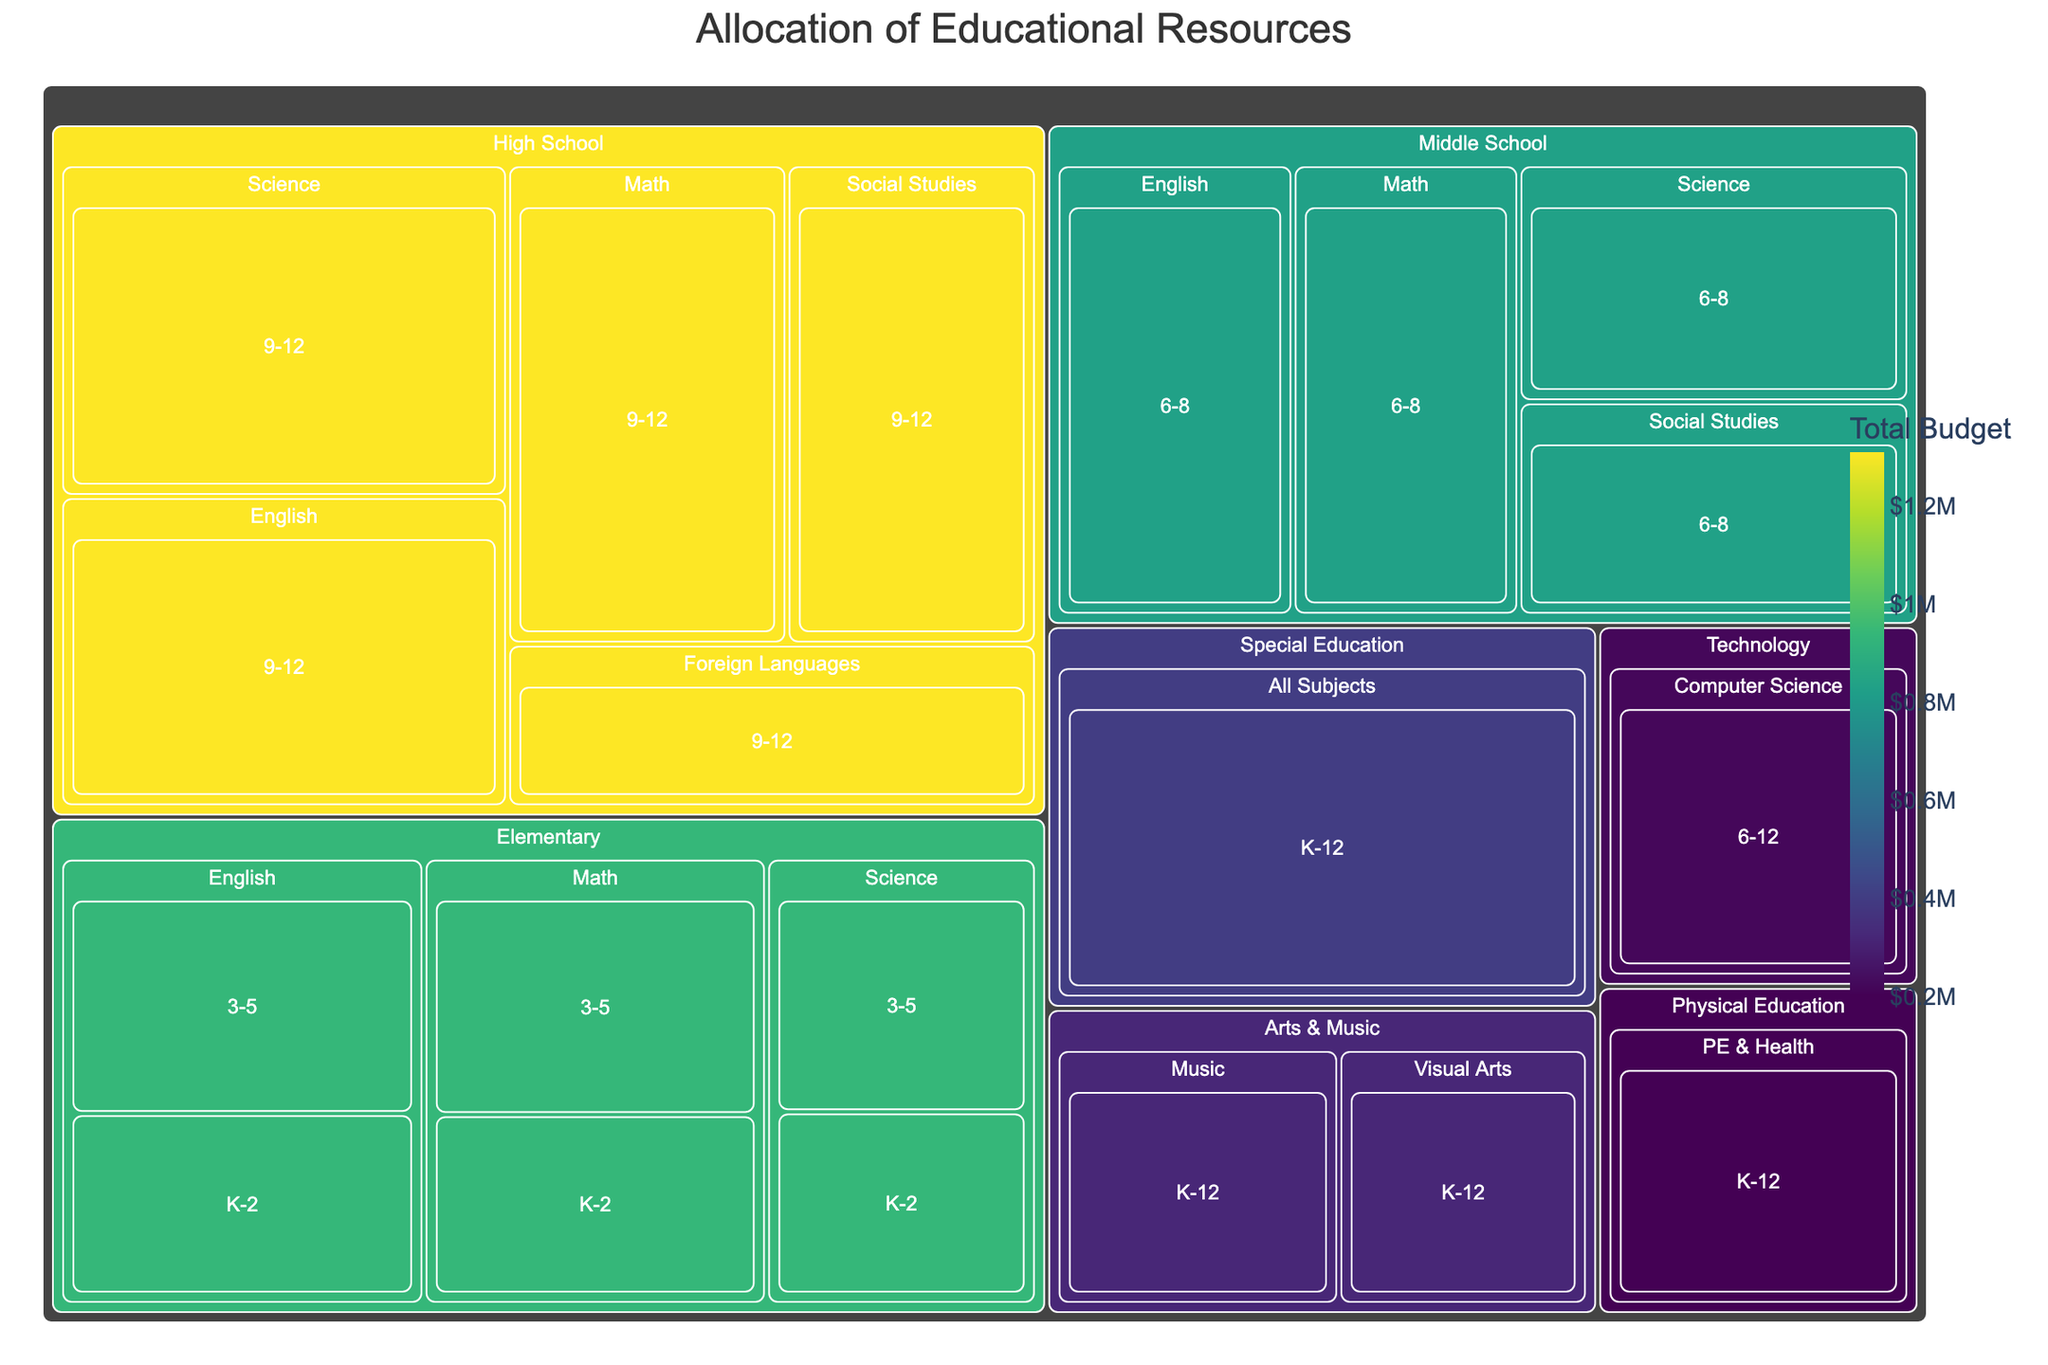Which department received the highest total budget? By examining the treemap, locate the department with the largest area, which indicates the highest total budget allocated. The color intensity can also guide you as it corresponds to the total budget.
Answer: Special Education What is the budget allocated to High School Science for grades 9-12? Navigate to the High School section in the treemap and find the Science subject for grades 9-12. The value displayed represents the budget.
Answer: $310,000 How does the budget for Computer Science in Middle and High School compare to the budget for Physical Education? Locate the Computer Science section under the Technology department and compare its budget to the Physical Education (PE & Health) section under Physical Education. Check the budget values to see which is higher.
Answer: Computer Science: $220,000, Physical Education: $200,000 Which subject in Elementary school for grades 3-5 has the highest budget? Within the Elementary school section, look at the subjects for grades 3-5 and compare their budgets. Identify the subject with the highest value.
Answer: English What is the total budget allocated to Middle School subjects? Sum the individual budgets for all Middle School subjects (Math, English, Science, Social Studies) by identifying their respective areas in the treemap and adding their values.
Answer: $830,000 Compare the budget for Math in Elementary school for grades K-2 with the budget for Elementary Science for grades 3-5. Which is higher and by how much? Locate the respective budgets for Math (K-2) and Science (3-5) under the Elementary section. Subtract the lower budget from the higher one to find the difference.
Answer: Math (K-2): $150,000, Science (3-5): $140,000, Difference: $10,000 What is the smallest budget allocated within the High School subjects? Within the High School section, scan through the subjects and identify the one with the smallest budget allocation.
Answer: Foreign Languages: $180,000 Which grade level has the highest budget in the Middle School Science subject? Look within the Middle School section under Science and compare the budget values for the specific grade levels.
Answer: 6-8 How do the combined budgets for Arts & Music compare to the budget for Technology? Identify and add the budgets for Visual Arts and Music in the Arts & Music department and compare the total to the budget for Technology (Computer Science).
Answer: Arts & Music: $320,000, Technology: $220,000 What is the budget allocated to Special Education, and how does it compare to the overall highest budget in any other single department? Find the budget allocation for Special Education and compare it to the highest budget from other departments by examining the largest areas and their values.
Answer: Special Education: $400,000, Higher than any other single department 